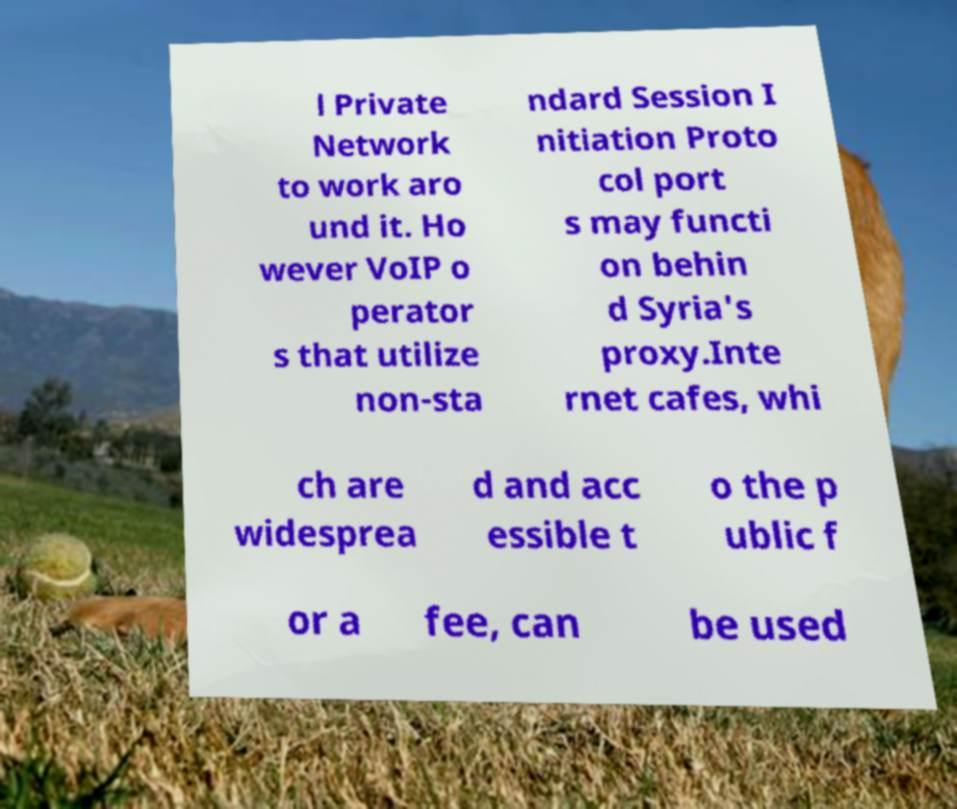Can you accurately transcribe the text from the provided image for me? l Private Network to work aro und it. Ho wever VoIP o perator s that utilize non-sta ndard Session I nitiation Proto col port s may functi on behin d Syria's proxy.Inte rnet cafes, whi ch are widesprea d and acc essible t o the p ublic f or a fee, can be used 